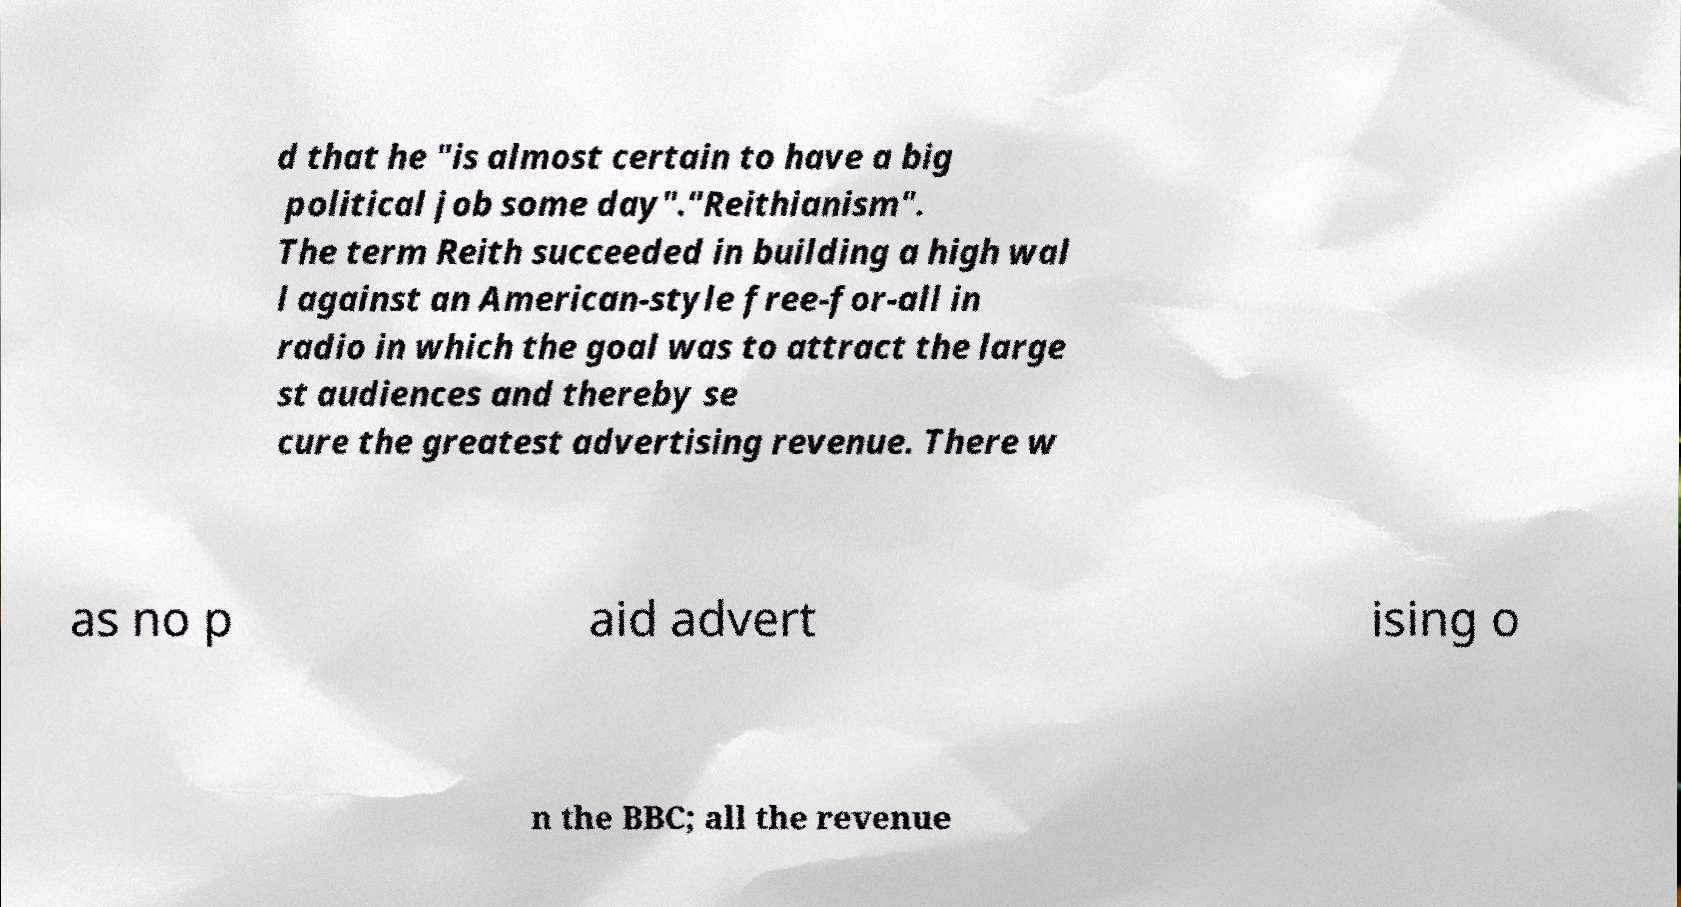Please read and relay the text visible in this image. What does it say? d that he "is almost certain to have a big political job some day"."Reithianism". The term Reith succeeded in building a high wal l against an American-style free-for-all in radio in which the goal was to attract the large st audiences and thereby se cure the greatest advertising revenue. There w as no p aid advert ising o n the BBC; all the revenue 